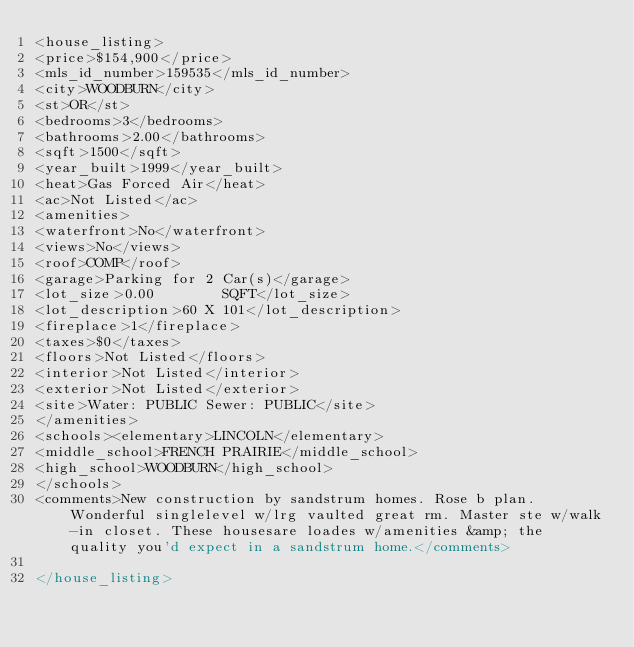Convert code to text. <code><loc_0><loc_0><loc_500><loc_500><_XML_><house_listing>
<price>$154,900</price>
<mls_id_number>159535</mls_id_number>
<city>WOODBURN</city>
<st>OR</st>
<bedrooms>3</bedrooms>
<bathrooms>2.00</bathrooms>
<sqft>1500</sqft>
<year_built>1999</year_built>
<heat>Gas Forced Air</heat>
<ac>Not Listed</ac>
<amenities>
<waterfront>No</waterfront>
<views>No</views>
<roof>COMP</roof>
<garage>Parking for 2 Car(s)</garage>
<lot_size>0.00        SQFT</lot_size>
<lot_description>60 X 101</lot_description>
<fireplace>1</fireplace>
<taxes>$0</taxes>
<floors>Not Listed</floors>
<interior>Not Listed</interior>
<exterior>Not Listed</exterior>
<site>Water: PUBLIC Sewer: PUBLIC</site>
</amenities>
<schools><elementary>LINCOLN</elementary>
<middle_school>FRENCH PRAIRIE</middle_school>
<high_school>WOODBURN</high_school>
</schools>
<comments>New construction by sandstrum homes. Rose b plan. Wonderful singlelevel w/lrg vaulted great rm. Master ste w/walk-in closet. These housesare loades w/amenities &amp; the quality you'd expect in a sandstrum home.</comments>

</house_listing>



</code> 